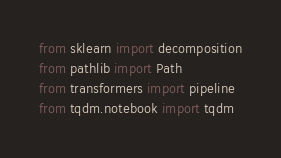<code> <loc_0><loc_0><loc_500><loc_500><_Python_>from sklearn import decomposition
from pathlib import Path
from transformers import pipeline
from tqdm.notebook import tqdm</code> 